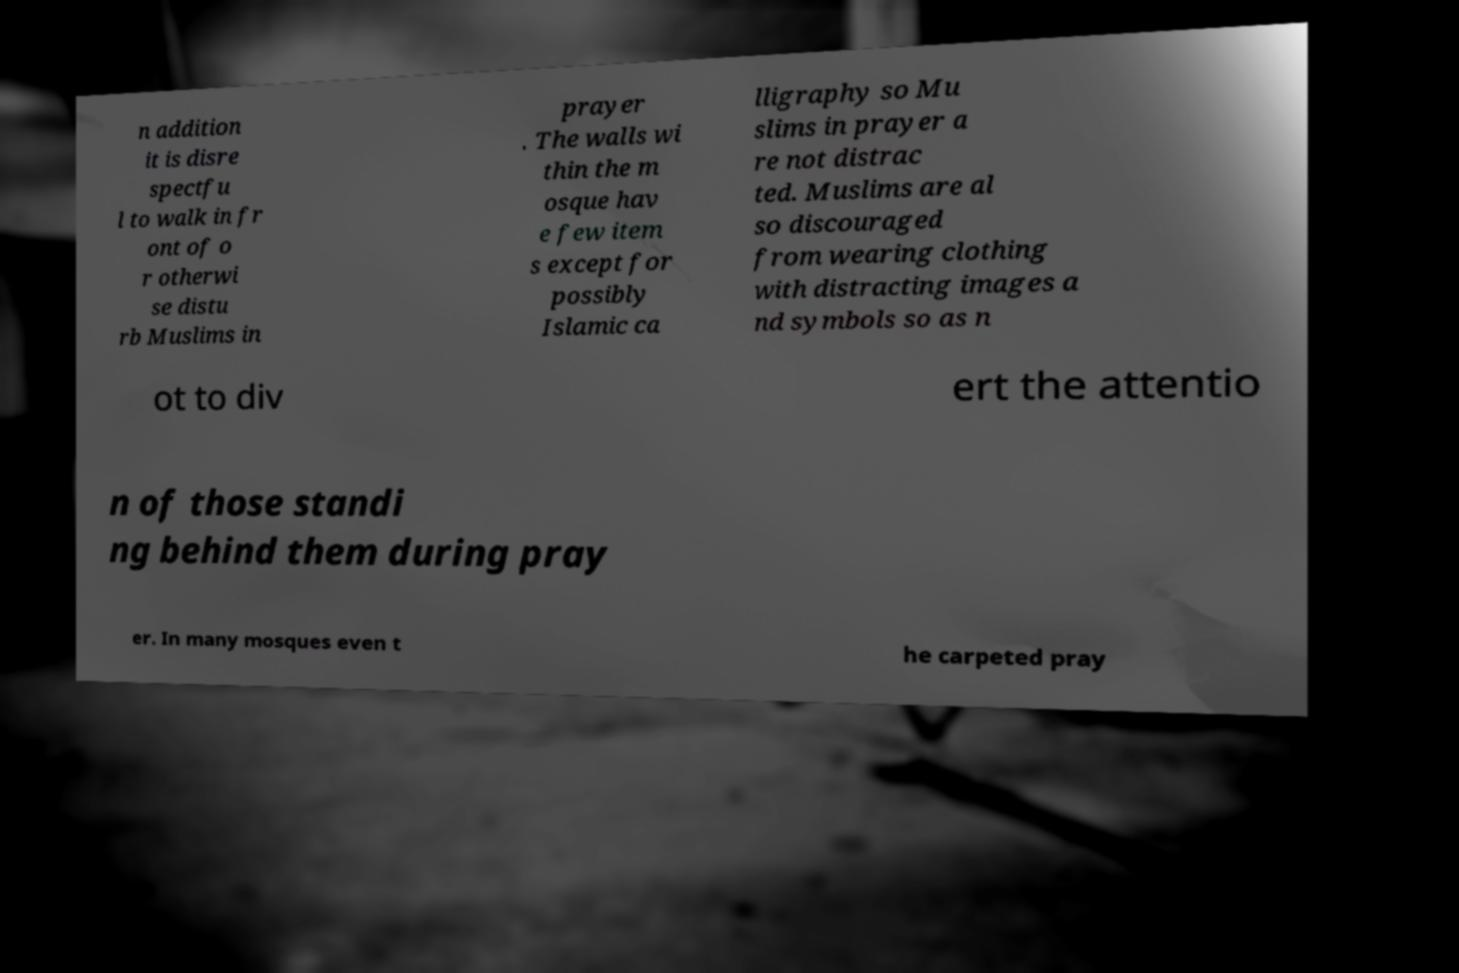Can you accurately transcribe the text from the provided image for me? n addition it is disre spectfu l to walk in fr ont of o r otherwi se distu rb Muslims in prayer . The walls wi thin the m osque hav e few item s except for possibly Islamic ca lligraphy so Mu slims in prayer a re not distrac ted. Muslims are al so discouraged from wearing clothing with distracting images a nd symbols so as n ot to div ert the attentio n of those standi ng behind them during pray er. In many mosques even t he carpeted pray 